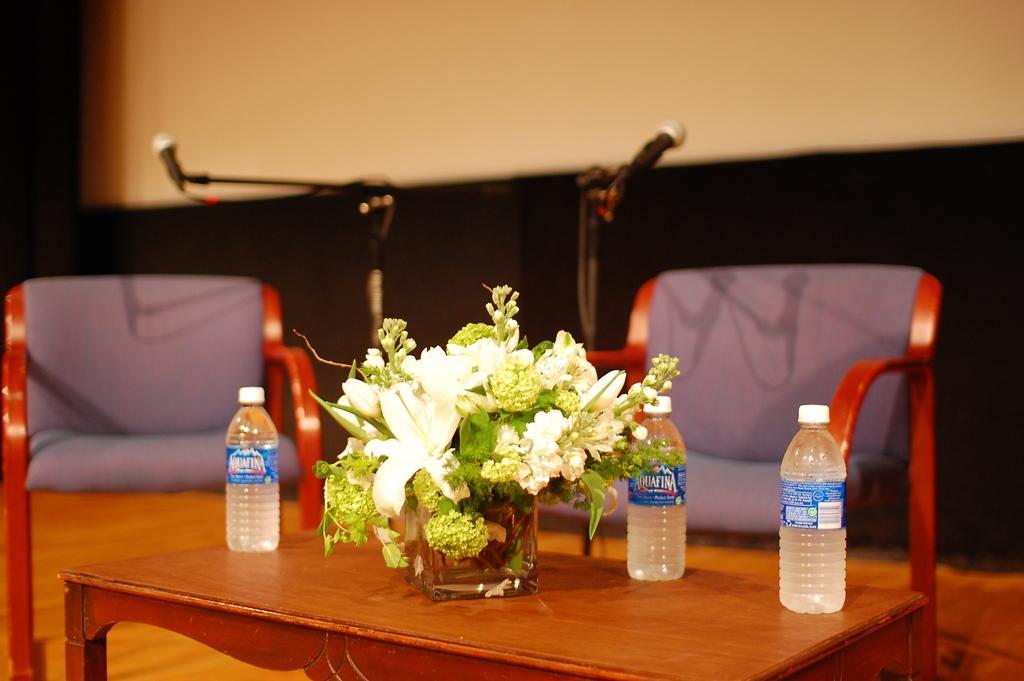Describe this image in one or two sentences. In this image i can see a flower pot, three bottles on a table at the back ground i can see two chairs, two micro phones and a wall. 